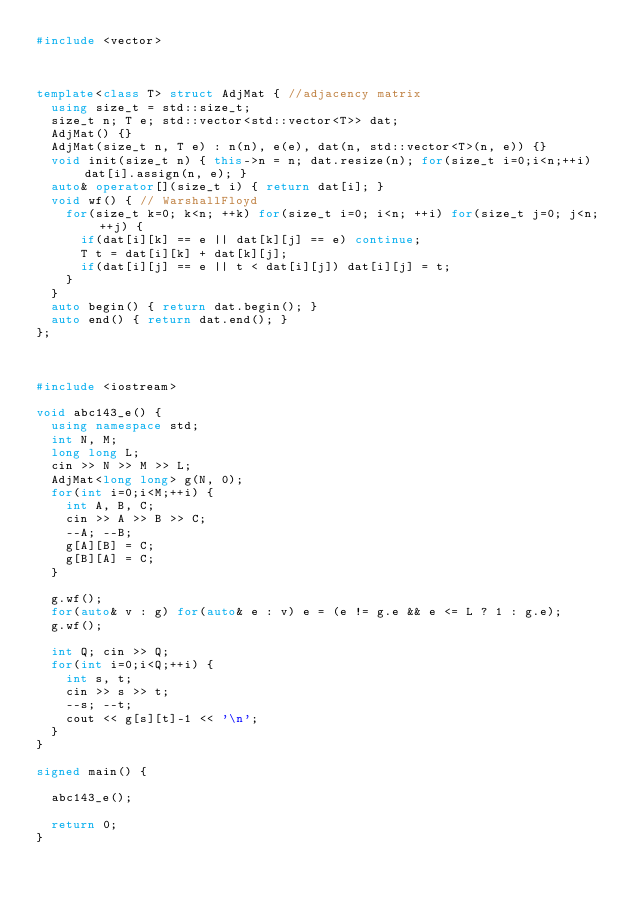<code> <loc_0><loc_0><loc_500><loc_500><_C++_>#include <vector>



template<class T> struct AdjMat { //adjacency matrix
  using size_t = std::size_t;
  size_t n; T e; std::vector<std::vector<T>> dat;
  AdjMat() {}
  AdjMat(size_t n, T e) : n(n), e(e), dat(n, std::vector<T>(n, e)) {}
  void init(size_t n) { this->n = n; dat.resize(n); for(size_t i=0;i<n;++i) dat[i].assign(n, e); }
  auto& operator[](size_t i) { return dat[i]; }
  void wf() { // WarshallFloyd
    for(size_t k=0; k<n; ++k) for(size_t i=0; i<n; ++i) for(size_t j=0; j<n; ++j) {
      if(dat[i][k] == e || dat[k][j] == e) continue;
      T t = dat[i][k] + dat[k][j];
      if(dat[i][j] == e || t < dat[i][j]) dat[i][j] = t;
    }
  }
  auto begin() { return dat.begin(); }
  auto end() { return dat.end(); }
};



#include <iostream>

void abc143_e() {
  using namespace std;
  int N, M;
  long long L;
  cin >> N >> M >> L;
  AdjMat<long long> g(N, 0);
  for(int i=0;i<M;++i) {
    int A, B, C;
    cin >> A >> B >> C;
    --A; --B;
    g[A][B] = C;
    g[B][A] = C;
  }

  g.wf();
  for(auto& v : g) for(auto& e : v) e = (e != g.e && e <= L ? 1 : g.e);
  g.wf();

  int Q; cin >> Q;
  for(int i=0;i<Q;++i) {
    int s, t;
    cin >> s >> t;
    --s; --t;
    cout << g[s][t]-1 << '\n';
  }
}

signed main() {

  abc143_e();

  return 0;
}
</code> 